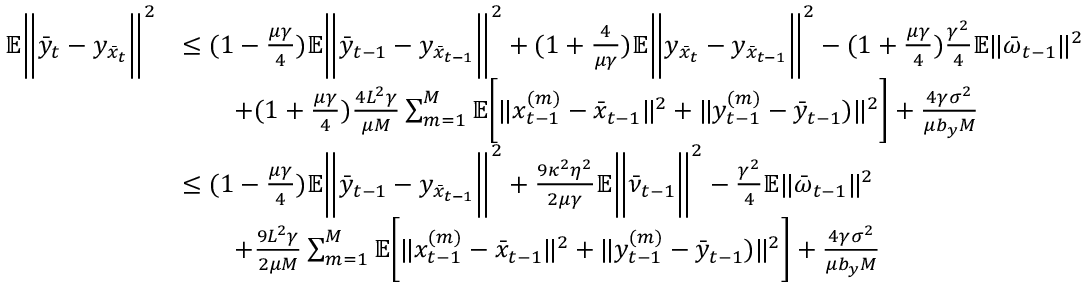Convert formula to latex. <formula><loc_0><loc_0><loc_500><loc_500>\begin{array} { r l } { \mathbb { E } \left \| \bar { y } _ { t } - y _ { \bar { x } _ { t } } \right \| ^ { 2 } } & { \leq ( 1 - \frac { \mu \gamma } { 4 } ) \mathbb { E } \left \| \bar { y } _ { t - 1 } - y _ { \bar { x } _ { t - 1 } } \right \| ^ { 2 } + ( 1 + \frac { 4 } { \mu \gamma } ) \mathbb { E } \left \| y _ { \bar { x } _ { t } } - y _ { \bar { x } _ { t - 1 } } \right \| ^ { 2 } - ( 1 + \frac { \mu \gamma } { 4 } ) \frac { \gamma ^ { 2 } } { 4 } \mathbb { E } \| \bar { \omega } _ { t - 1 } \| ^ { 2 } } \\ & { \quad + ( 1 + \frac { \mu \gamma } { 4 } ) \frac { 4 L ^ { 2 } \gamma } { \mu M } \sum _ { m = 1 } ^ { M } \mathbb { E } \left [ \| x _ { t - 1 } ^ { ( m ) } - \bar { x } _ { t - 1 } \| ^ { 2 } + \| y _ { t - 1 } ^ { ( m ) } - \bar { y } _ { t - 1 } ) \| ^ { 2 } \right ] + \frac { 4 \gamma \sigma ^ { 2 } } { \mu b _ { y } M } } \\ & { \leq ( 1 - \frac { \mu \gamma } { 4 } ) \mathbb { E } \left \| \bar { y } _ { t - 1 } - y _ { \bar { x } _ { t - 1 } } \right \| ^ { 2 } + \frac { 9 \kappa ^ { 2 } \eta ^ { 2 } } { 2 \mu \gamma } \mathbb { E } \left \| \bar { \nu } _ { t - 1 } \right \| ^ { 2 } - \frac { \gamma ^ { 2 } } { 4 } \mathbb { E } \| \bar { \omega } _ { t - 1 } \| ^ { 2 } } \\ & { \quad + \frac { 9 L ^ { 2 } \gamma } { 2 \mu M } \sum _ { m = 1 } ^ { M } \mathbb { E } \left [ \| x _ { t - 1 } ^ { ( m ) } - \bar { x } _ { t - 1 } \| ^ { 2 } + \| y _ { t - 1 } ^ { ( m ) } - \bar { y } _ { t - 1 } ) \| ^ { 2 } \right ] + \frac { 4 \gamma \sigma ^ { 2 } } { \mu b _ { y } M } } \end{array}</formula> 